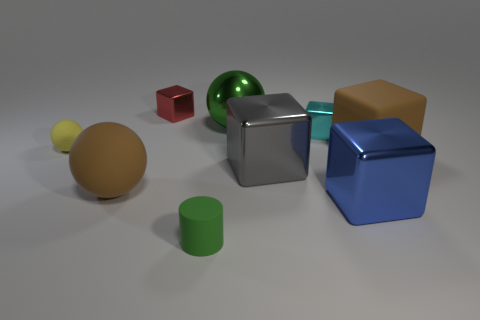Subtract all matte balls. How many balls are left? 1 Add 1 cyan spheres. How many objects exist? 10 Subtract all cylinders. How many objects are left? 8 Subtract all green spheres. How many spheres are left? 2 Add 7 gray shiny blocks. How many gray shiny blocks are left? 8 Add 2 large brown rubber cubes. How many large brown rubber cubes exist? 3 Subtract 0 red cylinders. How many objects are left? 9 Subtract 4 blocks. How many blocks are left? 1 Subtract all gray balls. Subtract all red blocks. How many balls are left? 3 Subtract all green balls. Subtract all green things. How many objects are left? 6 